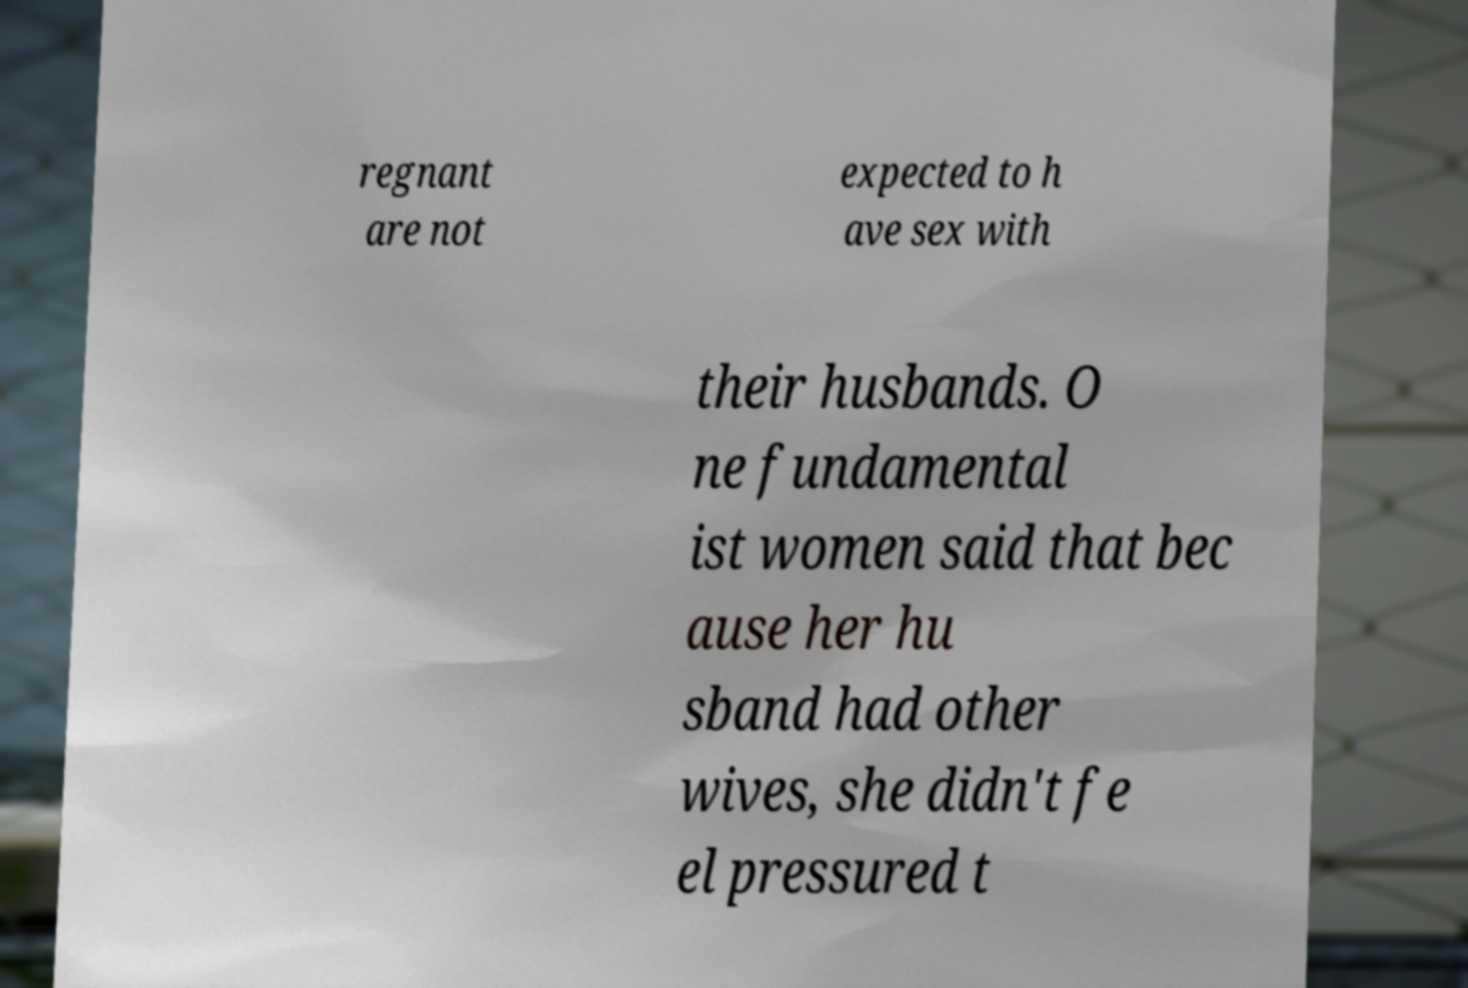I need the written content from this picture converted into text. Can you do that? regnant are not expected to h ave sex with their husbands. O ne fundamental ist women said that bec ause her hu sband had other wives, she didn't fe el pressured t 